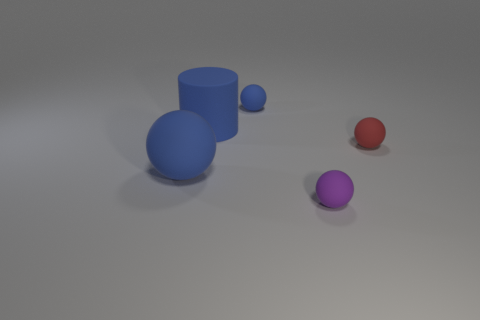Subtract all purple balls. How many balls are left? 3 Add 5 matte balls. How many objects exist? 10 Subtract all cyan spheres. Subtract all brown blocks. How many spheres are left? 4 Subtract all cylinders. How many objects are left? 4 Add 5 large gray blocks. How many large gray blocks exist? 5 Subtract 0 red cylinders. How many objects are left? 5 Subtract all tiny red things. Subtract all large cylinders. How many objects are left? 3 Add 4 red rubber spheres. How many red rubber spheres are left? 5 